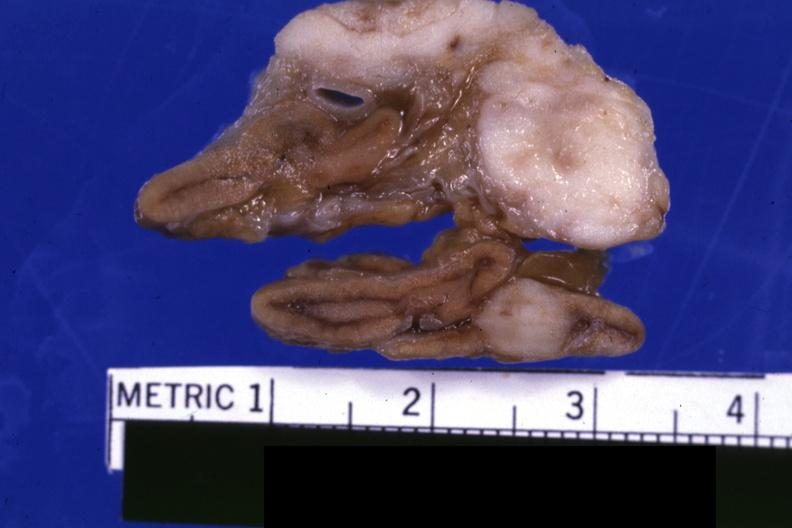what is present?
Answer the question using a single word or phrase. Endocrine 